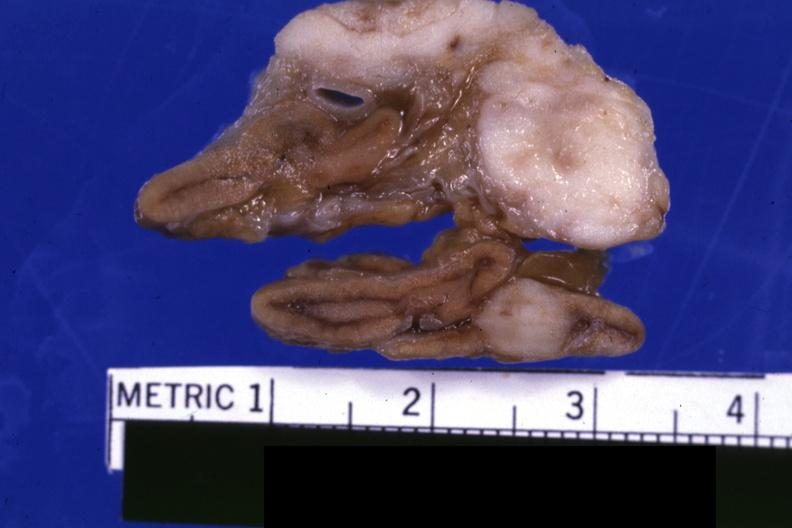what is present?
Answer the question using a single word or phrase. Endocrine 